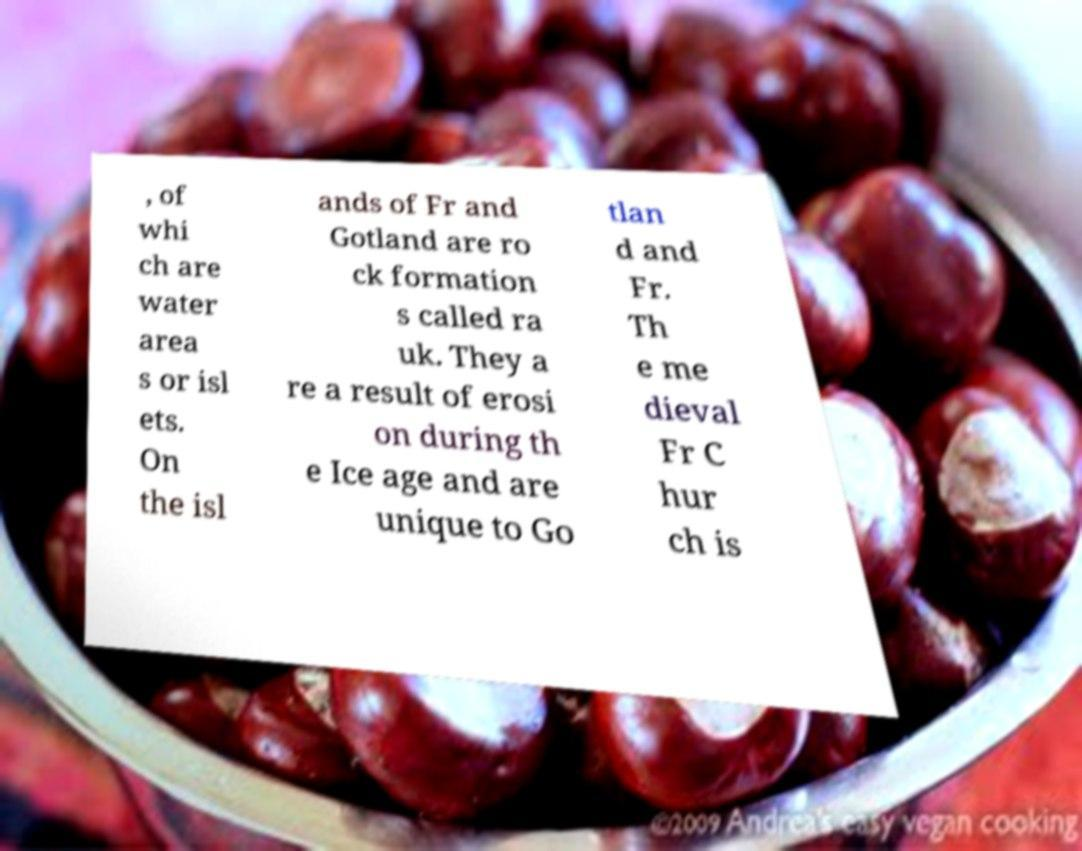Can you accurately transcribe the text from the provided image for me? , of whi ch are water area s or isl ets. On the isl ands of Fr and Gotland are ro ck formation s called ra uk. They a re a result of erosi on during th e Ice age and are unique to Go tlan d and Fr. Th e me dieval Fr C hur ch is 